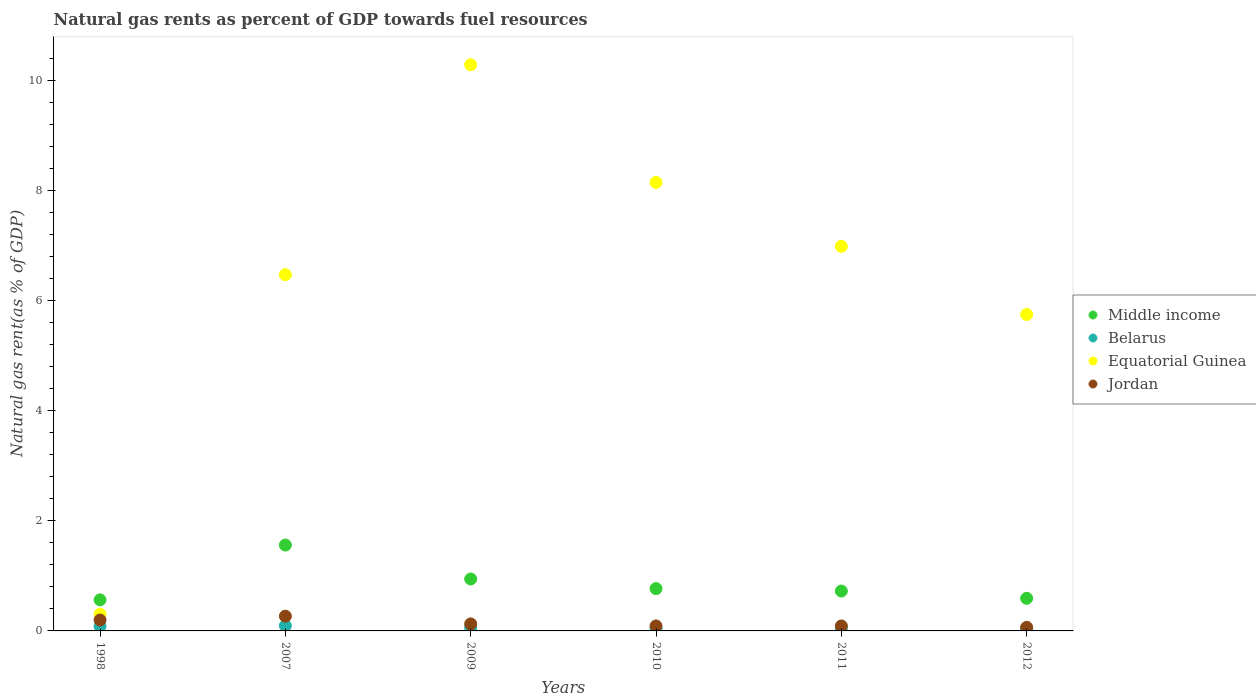How many different coloured dotlines are there?
Keep it short and to the point. 4. Is the number of dotlines equal to the number of legend labels?
Provide a succinct answer. Yes. What is the natural gas rent in Equatorial Guinea in 1998?
Offer a terse response. 0.31. Across all years, what is the maximum natural gas rent in Jordan?
Give a very brief answer. 0.27. Across all years, what is the minimum natural gas rent in Equatorial Guinea?
Keep it short and to the point. 0.31. In which year was the natural gas rent in Jordan maximum?
Keep it short and to the point. 2007. In which year was the natural gas rent in Middle income minimum?
Give a very brief answer. 1998. What is the total natural gas rent in Belarus in the graph?
Make the answer very short. 0.37. What is the difference between the natural gas rent in Jordan in 1998 and that in 2009?
Ensure brevity in your answer.  0.07. What is the difference between the natural gas rent in Middle income in 1998 and the natural gas rent in Belarus in 2012?
Your answer should be very brief. 0.53. What is the average natural gas rent in Middle income per year?
Provide a short and direct response. 0.86. In the year 2012, what is the difference between the natural gas rent in Middle income and natural gas rent in Belarus?
Your response must be concise. 0.56. In how many years, is the natural gas rent in Middle income greater than 8.8 %?
Offer a terse response. 0. What is the ratio of the natural gas rent in Jordan in 1998 to that in 2012?
Your answer should be very brief. 3.03. What is the difference between the highest and the second highest natural gas rent in Middle income?
Your answer should be very brief. 0.62. What is the difference between the highest and the lowest natural gas rent in Middle income?
Offer a very short reply. 0.99. In how many years, is the natural gas rent in Belarus greater than the average natural gas rent in Belarus taken over all years?
Your answer should be very brief. 2. Is the sum of the natural gas rent in Middle income in 1998 and 2007 greater than the maximum natural gas rent in Jordan across all years?
Provide a short and direct response. Yes. Is it the case that in every year, the sum of the natural gas rent in Equatorial Guinea and natural gas rent in Jordan  is greater than the sum of natural gas rent in Belarus and natural gas rent in Middle income?
Your response must be concise. Yes. Does the natural gas rent in Middle income monotonically increase over the years?
Provide a succinct answer. No. Is the natural gas rent in Jordan strictly greater than the natural gas rent in Belarus over the years?
Make the answer very short. Yes. How many dotlines are there?
Your response must be concise. 4. How many years are there in the graph?
Provide a short and direct response. 6. Are the values on the major ticks of Y-axis written in scientific E-notation?
Make the answer very short. No. How many legend labels are there?
Ensure brevity in your answer.  4. How are the legend labels stacked?
Keep it short and to the point. Vertical. What is the title of the graph?
Your answer should be compact. Natural gas rents as percent of GDP towards fuel resources. What is the label or title of the Y-axis?
Offer a terse response. Natural gas rent(as % of GDP). What is the Natural gas rent(as % of GDP) in Middle income in 1998?
Make the answer very short. 0.56. What is the Natural gas rent(as % of GDP) in Belarus in 1998?
Ensure brevity in your answer.  0.08. What is the Natural gas rent(as % of GDP) in Equatorial Guinea in 1998?
Give a very brief answer. 0.31. What is the Natural gas rent(as % of GDP) in Jordan in 1998?
Offer a very short reply. 0.2. What is the Natural gas rent(as % of GDP) of Middle income in 2007?
Ensure brevity in your answer.  1.56. What is the Natural gas rent(as % of GDP) of Belarus in 2007?
Make the answer very short. 0.1. What is the Natural gas rent(as % of GDP) in Equatorial Guinea in 2007?
Provide a succinct answer. 6.47. What is the Natural gas rent(as % of GDP) of Jordan in 2007?
Offer a very short reply. 0.27. What is the Natural gas rent(as % of GDP) in Middle income in 2009?
Ensure brevity in your answer.  0.94. What is the Natural gas rent(as % of GDP) in Belarus in 2009?
Provide a short and direct response. 0.06. What is the Natural gas rent(as % of GDP) in Equatorial Guinea in 2009?
Provide a succinct answer. 10.28. What is the Natural gas rent(as % of GDP) of Jordan in 2009?
Give a very brief answer. 0.13. What is the Natural gas rent(as % of GDP) in Middle income in 2010?
Your answer should be compact. 0.77. What is the Natural gas rent(as % of GDP) of Belarus in 2010?
Your response must be concise. 0.05. What is the Natural gas rent(as % of GDP) in Equatorial Guinea in 2010?
Your answer should be very brief. 8.14. What is the Natural gas rent(as % of GDP) of Jordan in 2010?
Your answer should be compact. 0.09. What is the Natural gas rent(as % of GDP) of Middle income in 2011?
Offer a terse response. 0.72. What is the Natural gas rent(as % of GDP) of Belarus in 2011?
Keep it short and to the point. 0.05. What is the Natural gas rent(as % of GDP) of Equatorial Guinea in 2011?
Provide a succinct answer. 6.98. What is the Natural gas rent(as % of GDP) of Jordan in 2011?
Your answer should be compact. 0.09. What is the Natural gas rent(as % of GDP) in Middle income in 2012?
Offer a terse response. 0.59. What is the Natural gas rent(as % of GDP) in Belarus in 2012?
Give a very brief answer. 0.04. What is the Natural gas rent(as % of GDP) in Equatorial Guinea in 2012?
Make the answer very short. 5.74. What is the Natural gas rent(as % of GDP) of Jordan in 2012?
Ensure brevity in your answer.  0.07. Across all years, what is the maximum Natural gas rent(as % of GDP) in Middle income?
Your answer should be very brief. 1.56. Across all years, what is the maximum Natural gas rent(as % of GDP) in Belarus?
Your answer should be compact. 0.1. Across all years, what is the maximum Natural gas rent(as % of GDP) in Equatorial Guinea?
Ensure brevity in your answer.  10.28. Across all years, what is the maximum Natural gas rent(as % of GDP) of Jordan?
Your response must be concise. 0.27. Across all years, what is the minimum Natural gas rent(as % of GDP) of Middle income?
Provide a short and direct response. 0.56. Across all years, what is the minimum Natural gas rent(as % of GDP) in Belarus?
Your answer should be very brief. 0.04. Across all years, what is the minimum Natural gas rent(as % of GDP) in Equatorial Guinea?
Give a very brief answer. 0.31. Across all years, what is the minimum Natural gas rent(as % of GDP) of Jordan?
Provide a succinct answer. 0.07. What is the total Natural gas rent(as % of GDP) of Middle income in the graph?
Your answer should be compact. 5.15. What is the total Natural gas rent(as % of GDP) in Belarus in the graph?
Provide a short and direct response. 0.37. What is the total Natural gas rent(as % of GDP) in Equatorial Guinea in the graph?
Give a very brief answer. 37.92. What is the total Natural gas rent(as % of GDP) of Jordan in the graph?
Give a very brief answer. 0.84. What is the difference between the Natural gas rent(as % of GDP) in Middle income in 1998 and that in 2007?
Your answer should be compact. -0.99. What is the difference between the Natural gas rent(as % of GDP) of Belarus in 1998 and that in 2007?
Offer a very short reply. -0.01. What is the difference between the Natural gas rent(as % of GDP) of Equatorial Guinea in 1998 and that in 2007?
Your answer should be very brief. -6.16. What is the difference between the Natural gas rent(as % of GDP) of Jordan in 1998 and that in 2007?
Your answer should be very brief. -0.07. What is the difference between the Natural gas rent(as % of GDP) of Middle income in 1998 and that in 2009?
Your response must be concise. -0.38. What is the difference between the Natural gas rent(as % of GDP) of Belarus in 1998 and that in 2009?
Offer a terse response. 0.03. What is the difference between the Natural gas rent(as % of GDP) in Equatorial Guinea in 1998 and that in 2009?
Your answer should be compact. -9.97. What is the difference between the Natural gas rent(as % of GDP) in Jordan in 1998 and that in 2009?
Offer a terse response. 0.07. What is the difference between the Natural gas rent(as % of GDP) in Middle income in 1998 and that in 2010?
Offer a very short reply. -0.2. What is the difference between the Natural gas rent(as % of GDP) of Belarus in 1998 and that in 2010?
Provide a succinct answer. 0.04. What is the difference between the Natural gas rent(as % of GDP) in Equatorial Guinea in 1998 and that in 2010?
Your answer should be compact. -7.84. What is the difference between the Natural gas rent(as % of GDP) in Jordan in 1998 and that in 2010?
Offer a terse response. 0.11. What is the difference between the Natural gas rent(as % of GDP) in Middle income in 1998 and that in 2011?
Offer a terse response. -0.16. What is the difference between the Natural gas rent(as % of GDP) of Belarus in 1998 and that in 2011?
Make the answer very short. 0.03. What is the difference between the Natural gas rent(as % of GDP) in Equatorial Guinea in 1998 and that in 2011?
Your answer should be compact. -6.68. What is the difference between the Natural gas rent(as % of GDP) in Jordan in 1998 and that in 2011?
Give a very brief answer. 0.11. What is the difference between the Natural gas rent(as % of GDP) of Middle income in 1998 and that in 2012?
Give a very brief answer. -0.03. What is the difference between the Natural gas rent(as % of GDP) of Belarus in 1998 and that in 2012?
Provide a short and direct response. 0.05. What is the difference between the Natural gas rent(as % of GDP) in Equatorial Guinea in 1998 and that in 2012?
Give a very brief answer. -5.44. What is the difference between the Natural gas rent(as % of GDP) of Jordan in 1998 and that in 2012?
Your answer should be very brief. 0.13. What is the difference between the Natural gas rent(as % of GDP) of Middle income in 2007 and that in 2009?
Your answer should be compact. 0.62. What is the difference between the Natural gas rent(as % of GDP) of Belarus in 2007 and that in 2009?
Keep it short and to the point. 0.04. What is the difference between the Natural gas rent(as % of GDP) of Equatorial Guinea in 2007 and that in 2009?
Your answer should be compact. -3.81. What is the difference between the Natural gas rent(as % of GDP) in Jordan in 2007 and that in 2009?
Give a very brief answer. 0.14. What is the difference between the Natural gas rent(as % of GDP) in Middle income in 2007 and that in 2010?
Your answer should be very brief. 0.79. What is the difference between the Natural gas rent(as % of GDP) of Belarus in 2007 and that in 2010?
Your answer should be compact. 0.05. What is the difference between the Natural gas rent(as % of GDP) of Equatorial Guinea in 2007 and that in 2010?
Ensure brevity in your answer.  -1.67. What is the difference between the Natural gas rent(as % of GDP) of Jordan in 2007 and that in 2010?
Your answer should be very brief. 0.18. What is the difference between the Natural gas rent(as % of GDP) of Middle income in 2007 and that in 2011?
Offer a terse response. 0.83. What is the difference between the Natural gas rent(as % of GDP) of Belarus in 2007 and that in 2011?
Your answer should be very brief. 0.05. What is the difference between the Natural gas rent(as % of GDP) of Equatorial Guinea in 2007 and that in 2011?
Your response must be concise. -0.51. What is the difference between the Natural gas rent(as % of GDP) in Jordan in 2007 and that in 2011?
Provide a short and direct response. 0.18. What is the difference between the Natural gas rent(as % of GDP) in Middle income in 2007 and that in 2012?
Offer a terse response. 0.97. What is the difference between the Natural gas rent(as % of GDP) in Belarus in 2007 and that in 2012?
Your answer should be compact. 0.06. What is the difference between the Natural gas rent(as % of GDP) of Equatorial Guinea in 2007 and that in 2012?
Offer a terse response. 0.72. What is the difference between the Natural gas rent(as % of GDP) in Jordan in 2007 and that in 2012?
Provide a succinct answer. 0.2. What is the difference between the Natural gas rent(as % of GDP) in Middle income in 2009 and that in 2010?
Provide a short and direct response. 0.17. What is the difference between the Natural gas rent(as % of GDP) in Belarus in 2009 and that in 2010?
Offer a very short reply. 0.01. What is the difference between the Natural gas rent(as % of GDP) in Equatorial Guinea in 2009 and that in 2010?
Give a very brief answer. 2.14. What is the difference between the Natural gas rent(as % of GDP) in Jordan in 2009 and that in 2010?
Make the answer very short. 0.04. What is the difference between the Natural gas rent(as % of GDP) of Middle income in 2009 and that in 2011?
Your response must be concise. 0.22. What is the difference between the Natural gas rent(as % of GDP) of Belarus in 2009 and that in 2011?
Offer a terse response. 0.01. What is the difference between the Natural gas rent(as % of GDP) in Equatorial Guinea in 2009 and that in 2011?
Keep it short and to the point. 3.3. What is the difference between the Natural gas rent(as % of GDP) of Jordan in 2009 and that in 2011?
Offer a terse response. 0.04. What is the difference between the Natural gas rent(as % of GDP) of Middle income in 2009 and that in 2012?
Offer a terse response. 0.35. What is the difference between the Natural gas rent(as % of GDP) of Belarus in 2009 and that in 2012?
Offer a very short reply. 0.02. What is the difference between the Natural gas rent(as % of GDP) of Equatorial Guinea in 2009 and that in 2012?
Provide a short and direct response. 4.53. What is the difference between the Natural gas rent(as % of GDP) of Jordan in 2009 and that in 2012?
Keep it short and to the point. 0.06. What is the difference between the Natural gas rent(as % of GDP) in Middle income in 2010 and that in 2011?
Provide a short and direct response. 0.04. What is the difference between the Natural gas rent(as % of GDP) of Belarus in 2010 and that in 2011?
Provide a short and direct response. -0. What is the difference between the Natural gas rent(as % of GDP) of Equatorial Guinea in 2010 and that in 2011?
Provide a succinct answer. 1.16. What is the difference between the Natural gas rent(as % of GDP) in Jordan in 2010 and that in 2011?
Your answer should be very brief. 0. What is the difference between the Natural gas rent(as % of GDP) in Middle income in 2010 and that in 2012?
Make the answer very short. 0.18. What is the difference between the Natural gas rent(as % of GDP) in Belarus in 2010 and that in 2012?
Make the answer very short. 0.01. What is the difference between the Natural gas rent(as % of GDP) in Equatorial Guinea in 2010 and that in 2012?
Give a very brief answer. 2.4. What is the difference between the Natural gas rent(as % of GDP) in Jordan in 2010 and that in 2012?
Offer a terse response. 0.03. What is the difference between the Natural gas rent(as % of GDP) of Middle income in 2011 and that in 2012?
Your answer should be compact. 0.13. What is the difference between the Natural gas rent(as % of GDP) in Belarus in 2011 and that in 2012?
Your answer should be compact. 0.01. What is the difference between the Natural gas rent(as % of GDP) in Equatorial Guinea in 2011 and that in 2012?
Provide a short and direct response. 1.24. What is the difference between the Natural gas rent(as % of GDP) in Jordan in 2011 and that in 2012?
Make the answer very short. 0.02. What is the difference between the Natural gas rent(as % of GDP) of Middle income in 1998 and the Natural gas rent(as % of GDP) of Belarus in 2007?
Your answer should be compact. 0.47. What is the difference between the Natural gas rent(as % of GDP) in Middle income in 1998 and the Natural gas rent(as % of GDP) in Equatorial Guinea in 2007?
Your answer should be very brief. -5.9. What is the difference between the Natural gas rent(as % of GDP) of Middle income in 1998 and the Natural gas rent(as % of GDP) of Jordan in 2007?
Keep it short and to the point. 0.3. What is the difference between the Natural gas rent(as % of GDP) of Belarus in 1998 and the Natural gas rent(as % of GDP) of Equatorial Guinea in 2007?
Offer a very short reply. -6.38. What is the difference between the Natural gas rent(as % of GDP) in Belarus in 1998 and the Natural gas rent(as % of GDP) in Jordan in 2007?
Provide a short and direct response. -0.18. What is the difference between the Natural gas rent(as % of GDP) in Equatorial Guinea in 1998 and the Natural gas rent(as % of GDP) in Jordan in 2007?
Your answer should be compact. 0.04. What is the difference between the Natural gas rent(as % of GDP) in Middle income in 1998 and the Natural gas rent(as % of GDP) in Belarus in 2009?
Offer a terse response. 0.51. What is the difference between the Natural gas rent(as % of GDP) in Middle income in 1998 and the Natural gas rent(as % of GDP) in Equatorial Guinea in 2009?
Offer a very short reply. -9.71. What is the difference between the Natural gas rent(as % of GDP) of Middle income in 1998 and the Natural gas rent(as % of GDP) of Jordan in 2009?
Offer a very short reply. 0.44. What is the difference between the Natural gas rent(as % of GDP) of Belarus in 1998 and the Natural gas rent(as % of GDP) of Equatorial Guinea in 2009?
Offer a terse response. -10.19. What is the difference between the Natural gas rent(as % of GDP) in Belarus in 1998 and the Natural gas rent(as % of GDP) in Jordan in 2009?
Offer a very short reply. -0.04. What is the difference between the Natural gas rent(as % of GDP) of Equatorial Guinea in 1998 and the Natural gas rent(as % of GDP) of Jordan in 2009?
Your answer should be very brief. 0.18. What is the difference between the Natural gas rent(as % of GDP) of Middle income in 1998 and the Natural gas rent(as % of GDP) of Belarus in 2010?
Make the answer very short. 0.52. What is the difference between the Natural gas rent(as % of GDP) in Middle income in 1998 and the Natural gas rent(as % of GDP) in Equatorial Guinea in 2010?
Your response must be concise. -7.58. What is the difference between the Natural gas rent(as % of GDP) of Middle income in 1998 and the Natural gas rent(as % of GDP) of Jordan in 2010?
Offer a terse response. 0.47. What is the difference between the Natural gas rent(as % of GDP) in Belarus in 1998 and the Natural gas rent(as % of GDP) in Equatorial Guinea in 2010?
Keep it short and to the point. -8.06. What is the difference between the Natural gas rent(as % of GDP) in Belarus in 1998 and the Natural gas rent(as % of GDP) in Jordan in 2010?
Offer a very short reply. -0.01. What is the difference between the Natural gas rent(as % of GDP) of Equatorial Guinea in 1998 and the Natural gas rent(as % of GDP) of Jordan in 2010?
Provide a succinct answer. 0.21. What is the difference between the Natural gas rent(as % of GDP) of Middle income in 1998 and the Natural gas rent(as % of GDP) of Belarus in 2011?
Offer a terse response. 0.52. What is the difference between the Natural gas rent(as % of GDP) in Middle income in 1998 and the Natural gas rent(as % of GDP) in Equatorial Guinea in 2011?
Offer a terse response. -6.42. What is the difference between the Natural gas rent(as % of GDP) of Middle income in 1998 and the Natural gas rent(as % of GDP) of Jordan in 2011?
Your answer should be compact. 0.47. What is the difference between the Natural gas rent(as % of GDP) of Belarus in 1998 and the Natural gas rent(as % of GDP) of Equatorial Guinea in 2011?
Make the answer very short. -6.9. What is the difference between the Natural gas rent(as % of GDP) of Belarus in 1998 and the Natural gas rent(as % of GDP) of Jordan in 2011?
Your response must be concise. -0.01. What is the difference between the Natural gas rent(as % of GDP) of Equatorial Guinea in 1998 and the Natural gas rent(as % of GDP) of Jordan in 2011?
Your answer should be very brief. 0.21. What is the difference between the Natural gas rent(as % of GDP) in Middle income in 1998 and the Natural gas rent(as % of GDP) in Belarus in 2012?
Your response must be concise. 0.53. What is the difference between the Natural gas rent(as % of GDP) in Middle income in 1998 and the Natural gas rent(as % of GDP) in Equatorial Guinea in 2012?
Offer a very short reply. -5.18. What is the difference between the Natural gas rent(as % of GDP) of Middle income in 1998 and the Natural gas rent(as % of GDP) of Jordan in 2012?
Give a very brief answer. 0.5. What is the difference between the Natural gas rent(as % of GDP) in Belarus in 1998 and the Natural gas rent(as % of GDP) in Equatorial Guinea in 2012?
Ensure brevity in your answer.  -5.66. What is the difference between the Natural gas rent(as % of GDP) of Belarus in 1998 and the Natural gas rent(as % of GDP) of Jordan in 2012?
Provide a succinct answer. 0.02. What is the difference between the Natural gas rent(as % of GDP) in Equatorial Guinea in 1998 and the Natural gas rent(as % of GDP) in Jordan in 2012?
Your answer should be very brief. 0.24. What is the difference between the Natural gas rent(as % of GDP) of Middle income in 2007 and the Natural gas rent(as % of GDP) of Belarus in 2009?
Ensure brevity in your answer.  1.5. What is the difference between the Natural gas rent(as % of GDP) of Middle income in 2007 and the Natural gas rent(as % of GDP) of Equatorial Guinea in 2009?
Your response must be concise. -8.72. What is the difference between the Natural gas rent(as % of GDP) of Middle income in 2007 and the Natural gas rent(as % of GDP) of Jordan in 2009?
Offer a terse response. 1.43. What is the difference between the Natural gas rent(as % of GDP) in Belarus in 2007 and the Natural gas rent(as % of GDP) in Equatorial Guinea in 2009?
Provide a succinct answer. -10.18. What is the difference between the Natural gas rent(as % of GDP) of Belarus in 2007 and the Natural gas rent(as % of GDP) of Jordan in 2009?
Your answer should be compact. -0.03. What is the difference between the Natural gas rent(as % of GDP) of Equatorial Guinea in 2007 and the Natural gas rent(as % of GDP) of Jordan in 2009?
Keep it short and to the point. 6.34. What is the difference between the Natural gas rent(as % of GDP) in Middle income in 2007 and the Natural gas rent(as % of GDP) in Belarus in 2010?
Give a very brief answer. 1.51. What is the difference between the Natural gas rent(as % of GDP) of Middle income in 2007 and the Natural gas rent(as % of GDP) of Equatorial Guinea in 2010?
Your answer should be compact. -6.58. What is the difference between the Natural gas rent(as % of GDP) in Middle income in 2007 and the Natural gas rent(as % of GDP) in Jordan in 2010?
Your answer should be compact. 1.47. What is the difference between the Natural gas rent(as % of GDP) of Belarus in 2007 and the Natural gas rent(as % of GDP) of Equatorial Guinea in 2010?
Provide a succinct answer. -8.05. What is the difference between the Natural gas rent(as % of GDP) of Belarus in 2007 and the Natural gas rent(as % of GDP) of Jordan in 2010?
Provide a succinct answer. 0. What is the difference between the Natural gas rent(as % of GDP) in Equatorial Guinea in 2007 and the Natural gas rent(as % of GDP) in Jordan in 2010?
Make the answer very short. 6.38. What is the difference between the Natural gas rent(as % of GDP) in Middle income in 2007 and the Natural gas rent(as % of GDP) in Belarus in 2011?
Your answer should be very brief. 1.51. What is the difference between the Natural gas rent(as % of GDP) in Middle income in 2007 and the Natural gas rent(as % of GDP) in Equatorial Guinea in 2011?
Make the answer very short. -5.42. What is the difference between the Natural gas rent(as % of GDP) of Middle income in 2007 and the Natural gas rent(as % of GDP) of Jordan in 2011?
Offer a very short reply. 1.47. What is the difference between the Natural gas rent(as % of GDP) of Belarus in 2007 and the Natural gas rent(as % of GDP) of Equatorial Guinea in 2011?
Your response must be concise. -6.89. What is the difference between the Natural gas rent(as % of GDP) of Belarus in 2007 and the Natural gas rent(as % of GDP) of Jordan in 2011?
Offer a terse response. 0.01. What is the difference between the Natural gas rent(as % of GDP) of Equatorial Guinea in 2007 and the Natural gas rent(as % of GDP) of Jordan in 2011?
Make the answer very short. 6.38. What is the difference between the Natural gas rent(as % of GDP) in Middle income in 2007 and the Natural gas rent(as % of GDP) in Belarus in 2012?
Keep it short and to the point. 1.52. What is the difference between the Natural gas rent(as % of GDP) in Middle income in 2007 and the Natural gas rent(as % of GDP) in Equatorial Guinea in 2012?
Your answer should be compact. -4.19. What is the difference between the Natural gas rent(as % of GDP) of Middle income in 2007 and the Natural gas rent(as % of GDP) of Jordan in 2012?
Make the answer very short. 1.49. What is the difference between the Natural gas rent(as % of GDP) in Belarus in 2007 and the Natural gas rent(as % of GDP) in Equatorial Guinea in 2012?
Keep it short and to the point. -5.65. What is the difference between the Natural gas rent(as % of GDP) of Equatorial Guinea in 2007 and the Natural gas rent(as % of GDP) of Jordan in 2012?
Your answer should be compact. 6.4. What is the difference between the Natural gas rent(as % of GDP) of Middle income in 2009 and the Natural gas rent(as % of GDP) of Belarus in 2010?
Provide a short and direct response. 0.9. What is the difference between the Natural gas rent(as % of GDP) of Middle income in 2009 and the Natural gas rent(as % of GDP) of Equatorial Guinea in 2010?
Offer a terse response. -7.2. What is the difference between the Natural gas rent(as % of GDP) of Middle income in 2009 and the Natural gas rent(as % of GDP) of Jordan in 2010?
Make the answer very short. 0.85. What is the difference between the Natural gas rent(as % of GDP) of Belarus in 2009 and the Natural gas rent(as % of GDP) of Equatorial Guinea in 2010?
Offer a very short reply. -8.09. What is the difference between the Natural gas rent(as % of GDP) of Belarus in 2009 and the Natural gas rent(as % of GDP) of Jordan in 2010?
Your answer should be very brief. -0.04. What is the difference between the Natural gas rent(as % of GDP) of Equatorial Guinea in 2009 and the Natural gas rent(as % of GDP) of Jordan in 2010?
Your answer should be very brief. 10.19. What is the difference between the Natural gas rent(as % of GDP) of Middle income in 2009 and the Natural gas rent(as % of GDP) of Belarus in 2011?
Your answer should be compact. 0.89. What is the difference between the Natural gas rent(as % of GDP) of Middle income in 2009 and the Natural gas rent(as % of GDP) of Equatorial Guinea in 2011?
Give a very brief answer. -6.04. What is the difference between the Natural gas rent(as % of GDP) in Middle income in 2009 and the Natural gas rent(as % of GDP) in Jordan in 2011?
Your answer should be very brief. 0.85. What is the difference between the Natural gas rent(as % of GDP) in Belarus in 2009 and the Natural gas rent(as % of GDP) in Equatorial Guinea in 2011?
Offer a terse response. -6.93. What is the difference between the Natural gas rent(as % of GDP) of Belarus in 2009 and the Natural gas rent(as % of GDP) of Jordan in 2011?
Keep it short and to the point. -0.03. What is the difference between the Natural gas rent(as % of GDP) in Equatorial Guinea in 2009 and the Natural gas rent(as % of GDP) in Jordan in 2011?
Keep it short and to the point. 10.19. What is the difference between the Natural gas rent(as % of GDP) in Middle income in 2009 and the Natural gas rent(as % of GDP) in Belarus in 2012?
Your response must be concise. 0.91. What is the difference between the Natural gas rent(as % of GDP) of Middle income in 2009 and the Natural gas rent(as % of GDP) of Equatorial Guinea in 2012?
Offer a terse response. -4.8. What is the difference between the Natural gas rent(as % of GDP) in Middle income in 2009 and the Natural gas rent(as % of GDP) in Jordan in 2012?
Your answer should be compact. 0.88. What is the difference between the Natural gas rent(as % of GDP) in Belarus in 2009 and the Natural gas rent(as % of GDP) in Equatorial Guinea in 2012?
Your answer should be compact. -5.69. What is the difference between the Natural gas rent(as % of GDP) in Belarus in 2009 and the Natural gas rent(as % of GDP) in Jordan in 2012?
Your response must be concise. -0.01. What is the difference between the Natural gas rent(as % of GDP) of Equatorial Guinea in 2009 and the Natural gas rent(as % of GDP) of Jordan in 2012?
Provide a short and direct response. 10.21. What is the difference between the Natural gas rent(as % of GDP) in Middle income in 2010 and the Natural gas rent(as % of GDP) in Belarus in 2011?
Make the answer very short. 0.72. What is the difference between the Natural gas rent(as % of GDP) of Middle income in 2010 and the Natural gas rent(as % of GDP) of Equatorial Guinea in 2011?
Provide a succinct answer. -6.21. What is the difference between the Natural gas rent(as % of GDP) in Middle income in 2010 and the Natural gas rent(as % of GDP) in Jordan in 2011?
Offer a terse response. 0.68. What is the difference between the Natural gas rent(as % of GDP) in Belarus in 2010 and the Natural gas rent(as % of GDP) in Equatorial Guinea in 2011?
Provide a succinct answer. -6.93. What is the difference between the Natural gas rent(as % of GDP) in Belarus in 2010 and the Natural gas rent(as % of GDP) in Jordan in 2011?
Ensure brevity in your answer.  -0.04. What is the difference between the Natural gas rent(as % of GDP) of Equatorial Guinea in 2010 and the Natural gas rent(as % of GDP) of Jordan in 2011?
Offer a very short reply. 8.05. What is the difference between the Natural gas rent(as % of GDP) in Middle income in 2010 and the Natural gas rent(as % of GDP) in Belarus in 2012?
Your answer should be very brief. 0.73. What is the difference between the Natural gas rent(as % of GDP) in Middle income in 2010 and the Natural gas rent(as % of GDP) in Equatorial Guinea in 2012?
Keep it short and to the point. -4.98. What is the difference between the Natural gas rent(as % of GDP) in Middle income in 2010 and the Natural gas rent(as % of GDP) in Jordan in 2012?
Your answer should be compact. 0.7. What is the difference between the Natural gas rent(as % of GDP) in Belarus in 2010 and the Natural gas rent(as % of GDP) in Equatorial Guinea in 2012?
Give a very brief answer. -5.7. What is the difference between the Natural gas rent(as % of GDP) of Belarus in 2010 and the Natural gas rent(as % of GDP) of Jordan in 2012?
Your response must be concise. -0.02. What is the difference between the Natural gas rent(as % of GDP) of Equatorial Guinea in 2010 and the Natural gas rent(as % of GDP) of Jordan in 2012?
Make the answer very short. 8.08. What is the difference between the Natural gas rent(as % of GDP) in Middle income in 2011 and the Natural gas rent(as % of GDP) in Belarus in 2012?
Keep it short and to the point. 0.69. What is the difference between the Natural gas rent(as % of GDP) in Middle income in 2011 and the Natural gas rent(as % of GDP) in Equatorial Guinea in 2012?
Make the answer very short. -5.02. What is the difference between the Natural gas rent(as % of GDP) of Middle income in 2011 and the Natural gas rent(as % of GDP) of Jordan in 2012?
Keep it short and to the point. 0.66. What is the difference between the Natural gas rent(as % of GDP) in Belarus in 2011 and the Natural gas rent(as % of GDP) in Equatorial Guinea in 2012?
Give a very brief answer. -5.7. What is the difference between the Natural gas rent(as % of GDP) in Belarus in 2011 and the Natural gas rent(as % of GDP) in Jordan in 2012?
Give a very brief answer. -0.02. What is the difference between the Natural gas rent(as % of GDP) of Equatorial Guinea in 2011 and the Natural gas rent(as % of GDP) of Jordan in 2012?
Provide a succinct answer. 6.92. What is the average Natural gas rent(as % of GDP) of Middle income per year?
Offer a very short reply. 0.86. What is the average Natural gas rent(as % of GDP) of Belarus per year?
Your answer should be very brief. 0.06. What is the average Natural gas rent(as % of GDP) of Equatorial Guinea per year?
Your answer should be compact. 6.32. What is the average Natural gas rent(as % of GDP) of Jordan per year?
Give a very brief answer. 0.14. In the year 1998, what is the difference between the Natural gas rent(as % of GDP) in Middle income and Natural gas rent(as % of GDP) in Belarus?
Provide a succinct answer. 0.48. In the year 1998, what is the difference between the Natural gas rent(as % of GDP) of Middle income and Natural gas rent(as % of GDP) of Equatorial Guinea?
Keep it short and to the point. 0.26. In the year 1998, what is the difference between the Natural gas rent(as % of GDP) of Middle income and Natural gas rent(as % of GDP) of Jordan?
Your answer should be compact. 0.37. In the year 1998, what is the difference between the Natural gas rent(as % of GDP) in Belarus and Natural gas rent(as % of GDP) in Equatorial Guinea?
Make the answer very short. -0.22. In the year 1998, what is the difference between the Natural gas rent(as % of GDP) of Belarus and Natural gas rent(as % of GDP) of Jordan?
Give a very brief answer. -0.11. In the year 1998, what is the difference between the Natural gas rent(as % of GDP) in Equatorial Guinea and Natural gas rent(as % of GDP) in Jordan?
Offer a very short reply. 0.11. In the year 2007, what is the difference between the Natural gas rent(as % of GDP) in Middle income and Natural gas rent(as % of GDP) in Belarus?
Provide a short and direct response. 1.46. In the year 2007, what is the difference between the Natural gas rent(as % of GDP) of Middle income and Natural gas rent(as % of GDP) of Equatorial Guinea?
Your response must be concise. -4.91. In the year 2007, what is the difference between the Natural gas rent(as % of GDP) in Middle income and Natural gas rent(as % of GDP) in Jordan?
Provide a succinct answer. 1.29. In the year 2007, what is the difference between the Natural gas rent(as % of GDP) in Belarus and Natural gas rent(as % of GDP) in Equatorial Guinea?
Offer a terse response. -6.37. In the year 2007, what is the difference between the Natural gas rent(as % of GDP) of Belarus and Natural gas rent(as % of GDP) of Jordan?
Keep it short and to the point. -0.17. In the year 2007, what is the difference between the Natural gas rent(as % of GDP) of Equatorial Guinea and Natural gas rent(as % of GDP) of Jordan?
Your answer should be compact. 6.2. In the year 2009, what is the difference between the Natural gas rent(as % of GDP) of Middle income and Natural gas rent(as % of GDP) of Belarus?
Ensure brevity in your answer.  0.89. In the year 2009, what is the difference between the Natural gas rent(as % of GDP) in Middle income and Natural gas rent(as % of GDP) in Equatorial Guinea?
Keep it short and to the point. -9.33. In the year 2009, what is the difference between the Natural gas rent(as % of GDP) of Middle income and Natural gas rent(as % of GDP) of Jordan?
Ensure brevity in your answer.  0.82. In the year 2009, what is the difference between the Natural gas rent(as % of GDP) of Belarus and Natural gas rent(as % of GDP) of Equatorial Guinea?
Your answer should be compact. -10.22. In the year 2009, what is the difference between the Natural gas rent(as % of GDP) of Belarus and Natural gas rent(as % of GDP) of Jordan?
Your answer should be compact. -0.07. In the year 2009, what is the difference between the Natural gas rent(as % of GDP) in Equatorial Guinea and Natural gas rent(as % of GDP) in Jordan?
Give a very brief answer. 10.15. In the year 2010, what is the difference between the Natural gas rent(as % of GDP) of Middle income and Natural gas rent(as % of GDP) of Belarus?
Your answer should be very brief. 0.72. In the year 2010, what is the difference between the Natural gas rent(as % of GDP) of Middle income and Natural gas rent(as % of GDP) of Equatorial Guinea?
Offer a very short reply. -7.37. In the year 2010, what is the difference between the Natural gas rent(as % of GDP) in Middle income and Natural gas rent(as % of GDP) in Jordan?
Your answer should be very brief. 0.68. In the year 2010, what is the difference between the Natural gas rent(as % of GDP) of Belarus and Natural gas rent(as % of GDP) of Equatorial Guinea?
Make the answer very short. -8.09. In the year 2010, what is the difference between the Natural gas rent(as % of GDP) in Belarus and Natural gas rent(as % of GDP) in Jordan?
Your response must be concise. -0.04. In the year 2010, what is the difference between the Natural gas rent(as % of GDP) in Equatorial Guinea and Natural gas rent(as % of GDP) in Jordan?
Your answer should be very brief. 8.05. In the year 2011, what is the difference between the Natural gas rent(as % of GDP) of Middle income and Natural gas rent(as % of GDP) of Belarus?
Offer a very short reply. 0.68. In the year 2011, what is the difference between the Natural gas rent(as % of GDP) in Middle income and Natural gas rent(as % of GDP) in Equatorial Guinea?
Provide a short and direct response. -6.26. In the year 2011, what is the difference between the Natural gas rent(as % of GDP) of Middle income and Natural gas rent(as % of GDP) of Jordan?
Make the answer very short. 0.63. In the year 2011, what is the difference between the Natural gas rent(as % of GDP) of Belarus and Natural gas rent(as % of GDP) of Equatorial Guinea?
Ensure brevity in your answer.  -6.93. In the year 2011, what is the difference between the Natural gas rent(as % of GDP) in Belarus and Natural gas rent(as % of GDP) in Jordan?
Offer a very short reply. -0.04. In the year 2011, what is the difference between the Natural gas rent(as % of GDP) in Equatorial Guinea and Natural gas rent(as % of GDP) in Jordan?
Offer a very short reply. 6.89. In the year 2012, what is the difference between the Natural gas rent(as % of GDP) in Middle income and Natural gas rent(as % of GDP) in Belarus?
Make the answer very short. 0.56. In the year 2012, what is the difference between the Natural gas rent(as % of GDP) of Middle income and Natural gas rent(as % of GDP) of Equatorial Guinea?
Ensure brevity in your answer.  -5.15. In the year 2012, what is the difference between the Natural gas rent(as % of GDP) of Middle income and Natural gas rent(as % of GDP) of Jordan?
Your answer should be compact. 0.53. In the year 2012, what is the difference between the Natural gas rent(as % of GDP) of Belarus and Natural gas rent(as % of GDP) of Equatorial Guinea?
Offer a very short reply. -5.71. In the year 2012, what is the difference between the Natural gas rent(as % of GDP) of Belarus and Natural gas rent(as % of GDP) of Jordan?
Keep it short and to the point. -0.03. In the year 2012, what is the difference between the Natural gas rent(as % of GDP) in Equatorial Guinea and Natural gas rent(as % of GDP) in Jordan?
Ensure brevity in your answer.  5.68. What is the ratio of the Natural gas rent(as % of GDP) in Middle income in 1998 to that in 2007?
Ensure brevity in your answer.  0.36. What is the ratio of the Natural gas rent(as % of GDP) in Belarus in 1998 to that in 2007?
Provide a succinct answer. 0.87. What is the ratio of the Natural gas rent(as % of GDP) in Equatorial Guinea in 1998 to that in 2007?
Offer a terse response. 0.05. What is the ratio of the Natural gas rent(as % of GDP) in Jordan in 1998 to that in 2007?
Provide a succinct answer. 0.74. What is the ratio of the Natural gas rent(as % of GDP) of Middle income in 1998 to that in 2009?
Ensure brevity in your answer.  0.6. What is the ratio of the Natural gas rent(as % of GDP) of Belarus in 1998 to that in 2009?
Ensure brevity in your answer.  1.5. What is the ratio of the Natural gas rent(as % of GDP) of Equatorial Guinea in 1998 to that in 2009?
Your answer should be very brief. 0.03. What is the ratio of the Natural gas rent(as % of GDP) in Jordan in 1998 to that in 2009?
Offer a terse response. 1.55. What is the ratio of the Natural gas rent(as % of GDP) in Middle income in 1998 to that in 2010?
Ensure brevity in your answer.  0.73. What is the ratio of the Natural gas rent(as % of GDP) of Belarus in 1998 to that in 2010?
Ensure brevity in your answer.  1.78. What is the ratio of the Natural gas rent(as % of GDP) of Equatorial Guinea in 1998 to that in 2010?
Provide a short and direct response. 0.04. What is the ratio of the Natural gas rent(as % of GDP) of Jordan in 1998 to that in 2010?
Provide a short and direct response. 2.18. What is the ratio of the Natural gas rent(as % of GDP) in Middle income in 1998 to that in 2011?
Your answer should be compact. 0.78. What is the ratio of the Natural gas rent(as % of GDP) in Belarus in 1998 to that in 2011?
Offer a terse response. 1.71. What is the ratio of the Natural gas rent(as % of GDP) of Equatorial Guinea in 1998 to that in 2011?
Offer a terse response. 0.04. What is the ratio of the Natural gas rent(as % of GDP) in Jordan in 1998 to that in 2011?
Keep it short and to the point. 2.19. What is the ratio of the Natural gas rent(as % of GDP) in Middle income in 1998 to that in 2012?
Your answer should be compact. 0.95. What is the ratio of the Natural gas rent(as % of GDP) of Belarus in 1998 to that in 2012?
Provide a succinct answer. 2.34. What is the ratio of the Natural gas rent(as % of GDP) in Equatorial Guinea in 1998 to that in 2012?
Your answer should be very brief. 0.05. What is the ratio of the Natural gas rent(as % of GDP) in Jordan in 1998 to that in 2012?
Provide a short and direct response. 3.03. What is the ratio of the Natural gas rent(as % of GDP) of Middle income in 2007 to that in 2009?
Keep it short and to the point. 1.65. What is the ratio of the Natural gas rent(as % of GDP) in Belarus in 2007 to that in 2009?
Ensure brevity in your answer.  1.72. What is the ratio of the Natural gas rent(as % of GDP) in Equatorial Guinea in 2007 to that in 2009?
Give a very brief answer. 0.63. What is the ratio of the Natural gas rent(as % of GDP) in Jordan in 2007 to that in 2009?
Your answer should be very brief. 2.1. What is the ratio of the Natural gas rent(as % of GDP) of Middle income in 2007 to that in 2010?
Give a very brief answer. 2.03. What is the ratio of the Natural gas rent(as % of GDP) of Belarus in 2007 to that in 2010?
Keep it short and to the point. 2.04. What is the ratio of the Natural gas rent(as % of GDP) in Equatorial Guinea in 2007 to that in 2010?
Keep it short and to the point. 0.79. What is the ratio of the Natural gas rent(as % of GDP) in Jordan in 2007 to that in 2010?
Offer a terse response. 2.95. What is the ratio of the Natural gas rent(as % of GDP) in Middle income in 2007 to that in 2011?
Make the answer very short. 2.15. What is the ratio of the Natural gas rent(as % of GDP) of Belarus in 2007 to that in 2011?
Offer a very short reply. 1.95. What is the ratio of the Natural gas rent(as % of GDP) in Equatorial Guinea in 2007 to that in 2011?
Keep it short and to the point. 0.93. What is the ratio of the Natural gas rent(as % of GDP) of Jordan in 2007 to that in 2011?
Your response must be concise. 2.97. What is the ratio of the Natural gas rent(as % of GDP) of Middle income in 2007 to that in 2012?
Provide a succinct answer. 2.63. What is the ratio of the Natural gas rent(as % of GDP) in Belarus in 2007 to that in 2012?
Your response must be concise. 2.68. What is the ratio of the Natural gas rent(as % of GDP) of Equatorial Guinea in 2007 to that in 2012?
Make the answer very short. 1.13. What is the ratio of the Natural gas rent(as % of GDP) in Jordan in 2007 to that in 2012?
Give a very brief answer. 4.1. What is the ratio of the Natural gas rent(as % of GDP) of Middle income in 2009 to that in 2010?
Make the answer very short. 1.23. What is the ratio of the Natural gas rent(as % of GDP) in Belarus in 2009 to that in 2010?
Make the answer very short. 1.19. What is the ratio of the Natural gas rent(as % of GDP) in Equatorial Guinea in 2009 to that in 2010?
Provide a succinct answer. 1.26. What is the ratio of the Natural gas rent(as % of GDP) in Jordan in 2009 to that in 2010?
Offer a terse response. 1.4. What is the ratio of the Natural gas rent(as % of GDP) of Middle income in 2009 to that in 2011?
Provide a succinct answer. 1.3. What is the ratio of the Natural gas rent(as % of GDP) in Belarus in 2009 to that in 2011?
Your answer should be compact. 1.14. What is the ratio of the Natural gas rent(as % of GDP) in Equatorial Guinea in 2009 to that in 2011?
Your answer should be compact. 1.47. What is the ratio of the Natural gas rent(as % of GDP) of Jordan in 2009 to that in 2011?
Your answer should be compact. 1.41. What is the ratio of the Natural gas rent(as % of GDP) in Middle income in 2009 to that in 2012?
Your answer should be compact. 1.59. What is the ratio of the Natural gas rent(as % of GDP) in Belarus in 2009 to that in 2012?
Keep it short and to the point. 1.56. What is the ratio of the Natural gas rent(as % of GDP) in Equatorial Guinea in 2009 to that in 2012?
Keep it short and to the point. 1.79. What is the ratio of the Natural gas rent(as % of GDP) in Jordan in 2009 to that in 2012?
Your answer should be compact. 1.95. What is the ratio of the Natural gas rent(as % of GDP) in Middle income in 2010 to that in 2011?
Ensure brevity in your answer.  1.06. What is the ratio of the Natural gas rent(as % of GDP) of Belarus in 2010 to that in 2011?
Provide a succinct answer. 0.96. What is the ratio of the Natural gas rent(as % of GDP) of Equatorial Guinea in 2010 to that in 2011?
Keep it short and to the point. 1.17. What is the ratio of the Natural gas rent(as % of GDP) in Jordan in 2010 to that in 2011?
Keep it short and to the point. 1.01. What is the ratio of the Natural gas rent(as % of GDP) of Middle income in 2010 to that in 2012?
Your answer should be compact. 1.3. What is the ratio of the Natural gas rent(as % of GDP) of Belarus in 2010 to that in 2012?
Ensure brevity in your answer.  1.31. What is the ratio of the Natural gas rent(as % of GDP) of Equatorial Guinea in 2010 to that in 2012?
Your answer should be very brief. 1.42. What is the ratio of the Natural gas rent(as % of GDP) of Jordan in 2010 to that in 2012?
Provide a succinct answer. 1.39. What is the ratio of the Natural gas rent(as % of GDP) of Middle income in 2011 to that in 2012?
Provide a short and direct response. 1.22. What is the ratio of the Natural gas rent(as % of GDP) in Belarus in 2011 to that in 2012?
Your answer should be compact. 1.37. What is the ratio of the Natural gas rent(as % of GDP) in Equatorial Guinea in 2011 to that in 2012?
Your response must be concise. 1.22. What is the ratio of the Natural gas rent(as % of GDP) of Jordan in 2011 to that in 2012?
Provide a succinct answer. 1.38. What is the difference between the highest and the second highest Natural gas rent(as % of GDP) in Middle income?
Give a very brief answer. 0.62. What is the difference between the highest and the second highest Natural gas rent(as % of GDP) of Belarus?
Provide a short and direct response. 0.01. What is the difference between the highest and the second highest Natural gas rent(as % of GDP) of Equatorial Guinea?
Offer a terse response. 2.14. What is the difference between the highest and the second highest Natural gas rent(as % of GDP) of Jordan?
Your answer should be compact. 0.07. What is the difference between the highest and the lowest Natural gas rent(as % of GDP) of Middle income?
Offer a very short reply. 0.99. What is the difference between the highest and the lowest Natural gas rent(as % of GDP) in Belarus?
Provide a succinct answer. 0.06. What is the difference between the highest and the lowest Natural gas rent(as % of GDP) of Equatorial Guinea?
Ensure brevity in your answer.  9.97. What is the difference between the highest and the lowest Natural gas rent(as % of GDP) in Jordan?
Keep it short and to the point. 0.2. 